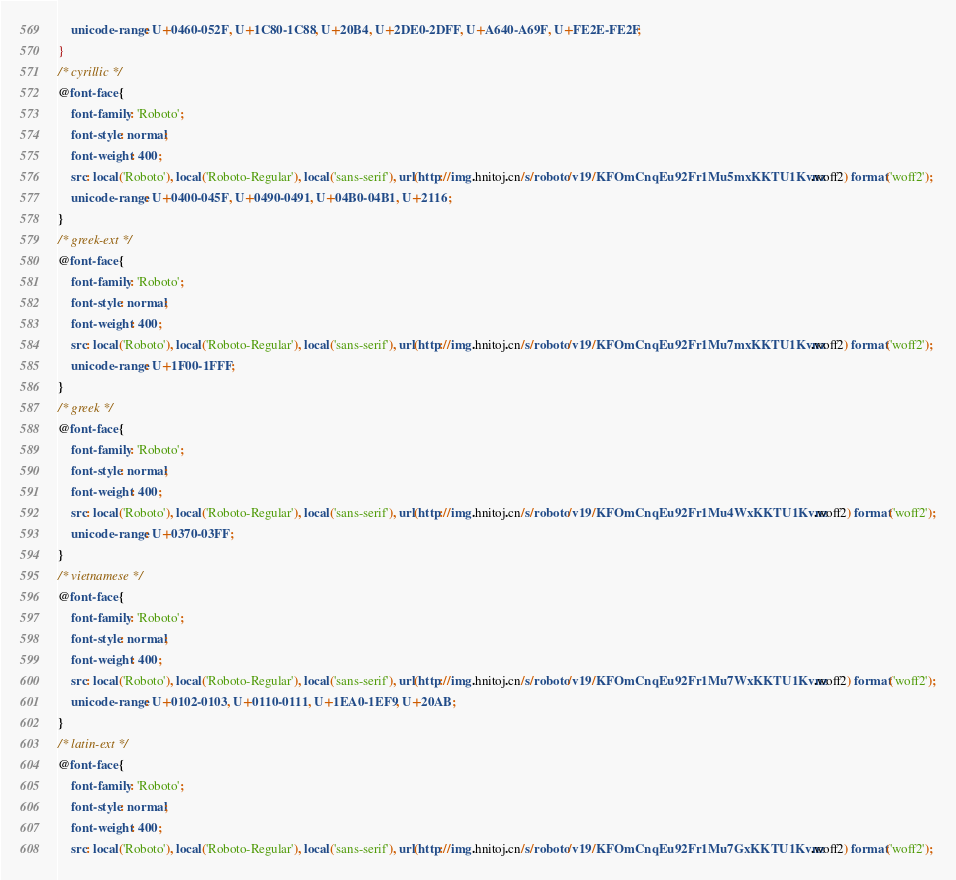<code> <loc_0><loc_0><loc_500><loc_500><_CSS_>    unicode-range: U+0460-052F, U+1C80-1C88, U+20B4, U+2DE0-2DFF, U+A640-A69F, U+FE2E-FE2F;
}
/* cyrillic */
@font-face {
    font-family: 'Roboto';
    font-style: normal;
    font-weight: 400;
    src: local('Roboto'), local('Roboto-Regular'), local('sans-serif'), url(http://img.hnitoj.cn/s/roboto/v19/KFOmCnqEu92Fr1Mu5mxKKTU1Kvnz.woff2) format('woff2');
    unicode-range: U+0400-045F, U+0490-0491, U+04B0-04B1, U+2116;
}
/* greek-ext */
@font-face {
    font-family: 'Roboto';
    font-style: normal;
    font-weight: 400;
    src: local('Roboto'), local('Roboto-Regular'), local('sans-serif'), url(http://img.hnitoj.cn/s/roboto/v19/KFOmCnqEu92Fr1Mu7mxKKTU1Kvnz.woff2) format('woff2');
    unicode-range: U+1F00-1FFF;
}
/* greek */
@font-face {
    font-family: 'Roboto';
    font-style: normal;
    font-weight: 400;
    src: local('Roboto'), local('Roboto-Regular'), local('sans-serif'), url(http://img.hnitoj.cn/s/roboto/v19/KFOmCnqEu92Fr1Mu4WxKKTU1Kvnz.woff2) format('woff2');
    unicode-range: U+0370-03FF;
}
/* vietnamese */
@font-face {
    font-family: 'Roboto';
    font-style: normal;
    font-weight: 400;
    src: local('Roboto'), local('Roboto-Regular'), local('sans-serif'), url(http://img.hnitoj.cn/s/roboto/v19/KFOmCnqEu92Fr1Mu7WxKKTU1Kvnz.woff2) format('woff2');
    unicode-range: U+0102-0103, U+0110-0111, U+1EA0-1EF9, U+20AB;
}
/* latin-ext */
@font-face {
    font-family: 'Roboto';
    font-style: normal;
    font-weight: 400;
    src: local('Roboto'), local('Roboto-Regular'), local('sans-serif'), url(http://img.hnitoj.cn/s/roboto/v19/KFOmCnqEu92Fr1Mu7GxKKTU1Kvnz.woff2) format('woff2');</code> 